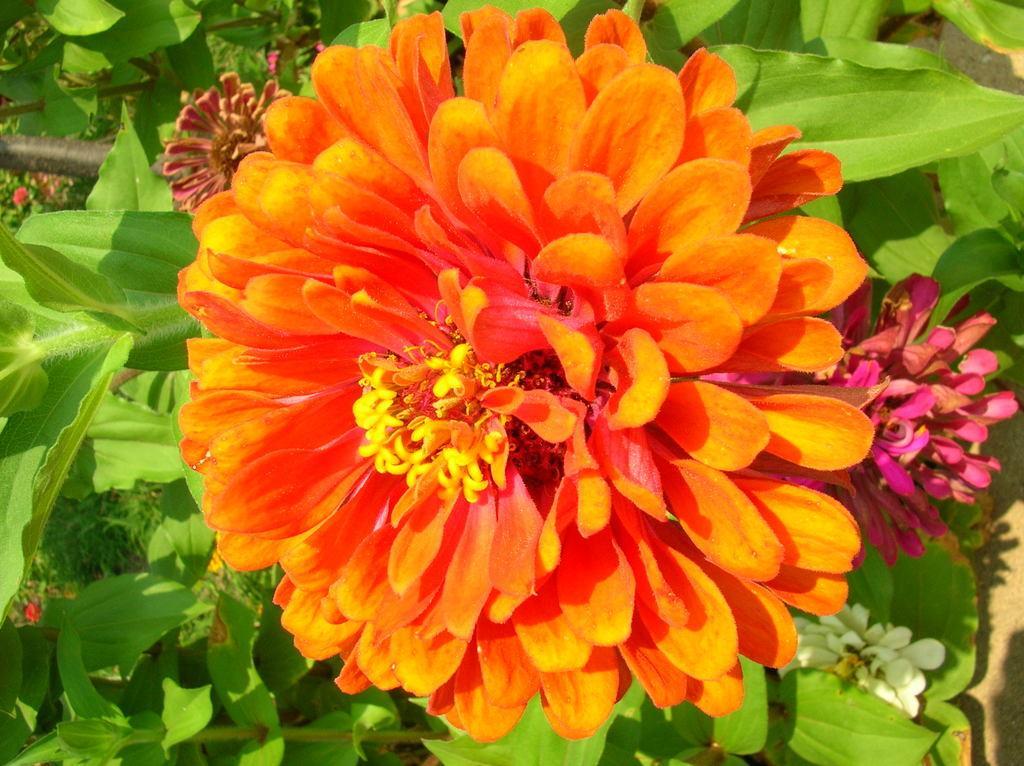Describe this image in one or two sentences. The picture consists of flowers and plants. On the left there is a black color object. 